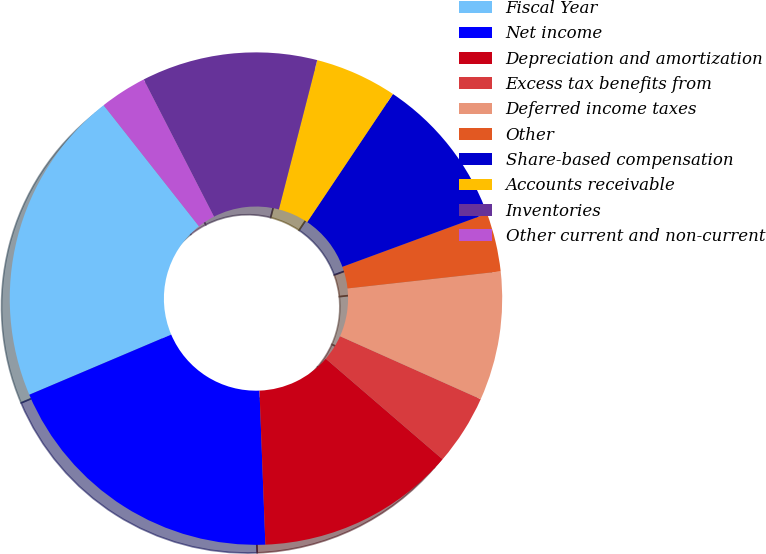Convert chart to OTSL. <chart><loc_0><loc_0><loc_500><loc_500><pie_chart><fcel>Fiscal Year<fcel>Net income<fcel>Depreciation and amortization<fcel>Excess tax benefits from<fcel>Deferred income taxes<fcel>Other<fcel>Share-based compensation<fcel>Accounts receivable<fcel>Inventories<fcel>Other current and non-current<nl><fcel>20.77%<fcel>19.23%<fcel>13.08%<fcel>4.62%<fcel>8.46%<fcel>3.85%<fcel>10.0%<fcel>5.39%<fcel>11.54%<fcel>3.08%<nl></chart> 